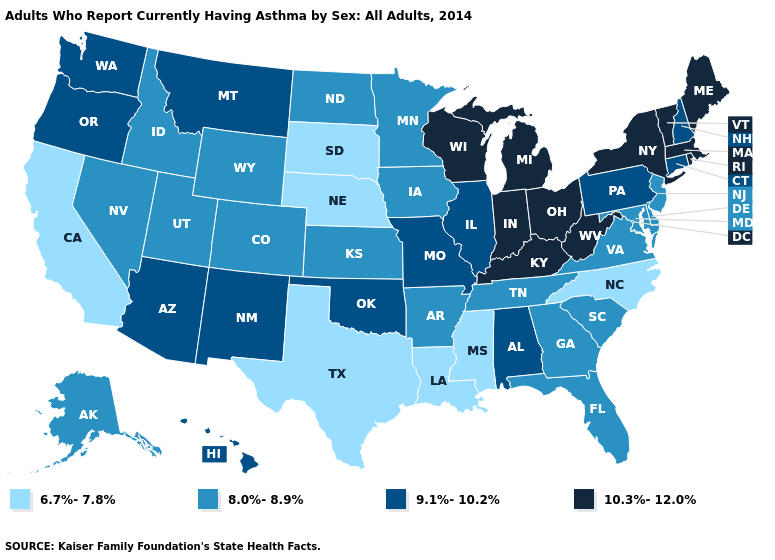What is the highest value in the USA?
Concise answer only. 10.3%-12.0%. What is the value of Hawaii?
Give a very brief answer. 9.1%-10.2%. How many symbols are there in the legend?
Short answer required. 4. Which states have the lowest value in the USA?
Concise answer only. California, Louisiana, Mississippi, Nebraska, North Carolina, South Dakota, Texas. Which states hav the highest value in the Northeast?
Answer briefly. Maine, Massachusetts, New York, Rhode Island, Vermont. Which states hav the highest value in the West?
Concise answer only. Arizona, Hawaii, Montana, New Mexico, Oregon, Washington. Is the legend a continuous bar?
Quick response, please. No. What is the value of Ohio?
Short answer required. 10.3%-12.0%. What is the highest value in the West ?
Give a very brief answer. 9.1%-10.2%. Which states have the lowest value in the Northeast?
Concise answer only. New Jersey. What is the lowest value in states that border Michigan?
Write a very short answer. 10.3%-12.0%. What is the value of Kentucky?
Write a very short answer. 10.3%-12.0%. Does Connecticut have the lowest value in the USA?
Answer briefly. No. What is the highest value in the USA?
Answer briefly. 10.3%-12.0%. Name the states that have a value in the range 10.3%-12.0%?
Concise answer only. Indiana, Kentucky, Maine, Massachusetts, Michigan, New York, Ohio, Rhode Island, Vermont, West Virginia, Wisconsin. 